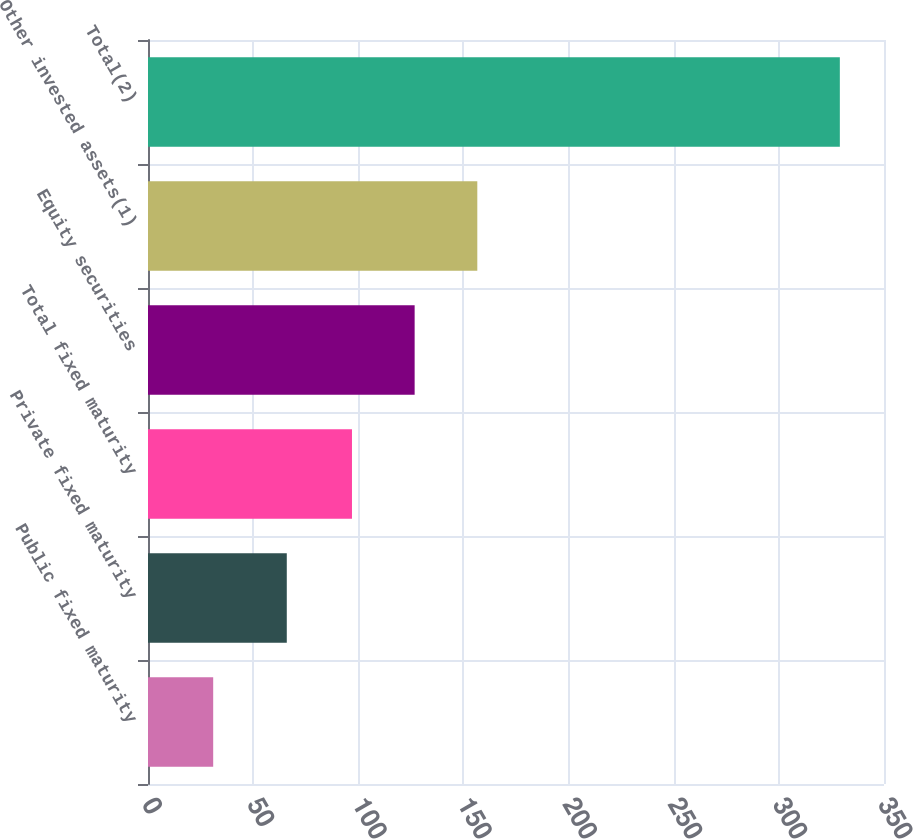Convert chart. <chart><loc_0><loc_0><loc_500><loc_500><bar_chart><fcel>Public fixed maturity<fcel>Private fixed maturity<fcel>Total fixed maturity<fcel>Equity securities<fcel>Other invested assets(1)<fcel>Total(2)<nl><fcel>31<fcel>66<fcel>97<fcel>126.8<fcel>156.6<fcel>329<nl></chart> 